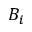<formula> <loc_0><loc_0><loc_500><loc_500>B _ { i }</formula> 